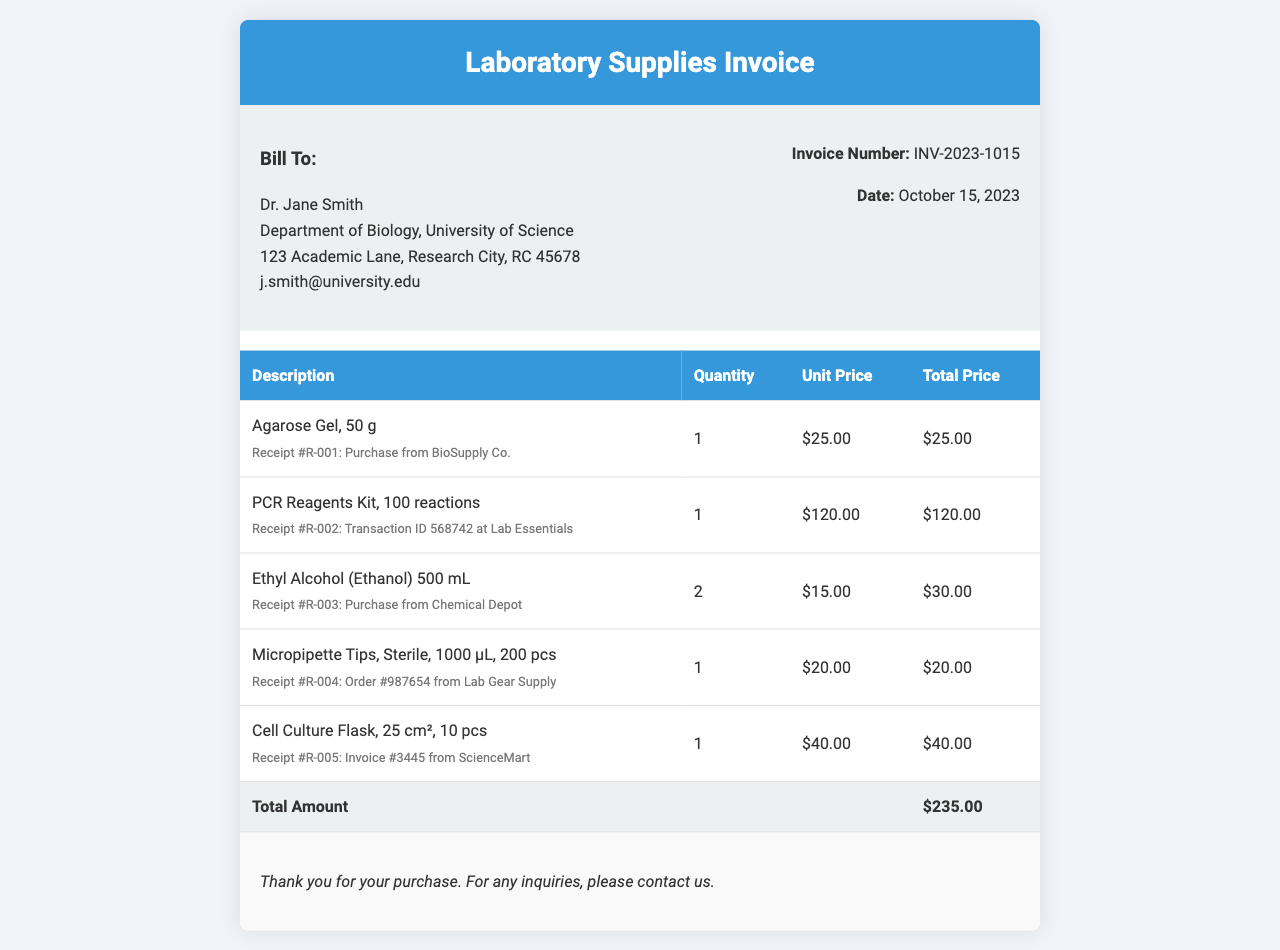What is the invoice number? The invoice number is specified in the document header, providing a unique identifier for the invoice.
Answer: INV-2023-1015 Who is billed for the invoice? The "Bill To" section contains the name of the person or organization being charged, which is essential for identifying the recipient.
Answer: Dr. Jane Smith What is the total amount of the invoice? The total amount is found in the last row of the invoice table, summarizing the total cost of items purchased.
Answer: $235.00 How many Agarose Gel packages were purchased? The quantity of each item purchased is listed in the table; specifically for Agarose Gel, it's essential to know how many were bought.
Answer: 1 What is the cost of the PCR Reagents Kit? The unit price for each item in the invoice table is provided, which allows calculation of total expenditure on specific items.
Answer: $120.00 Which company supplied the Ethyl Alcohol? Each item lists a description along with a receipt number and supplier information, which identifies where items were sourced from.
Answer: Chemical Depot What is the date of the invoice? The invoice date is specified in the invoice details, indicating when the transaction occurred.
Answer: October 15, 2023 How many pieces are in a package of Micropipette Tips? Each item's description indicates the packaging details which refer to the number or quantity contained within it.
Answer: 200 pcs 